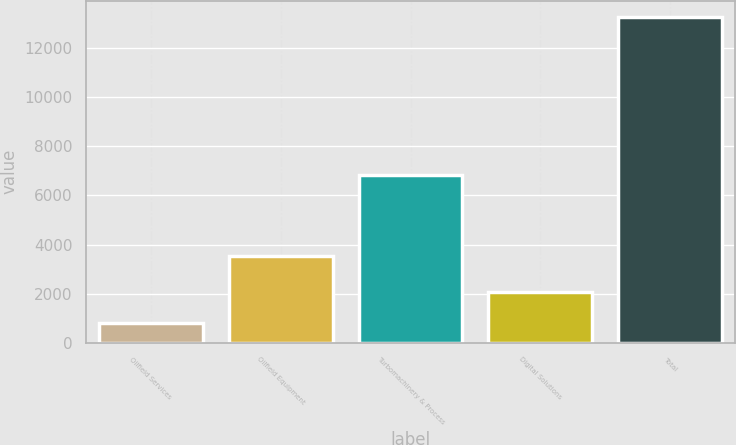Convert chart to OTSL. <chart><loc_0><loc_0><loc_500><loc_500><bar_chart><fcel>Oilfield Services<fcel>Oilfield Equipment<fcel>Turbomachinery & Process<fcel>Digital Solutions<fcel>Total<nl><fcel>799<fcel>3547<fcel>6837<fcel>2086<fcel>13269<nl></chart> 